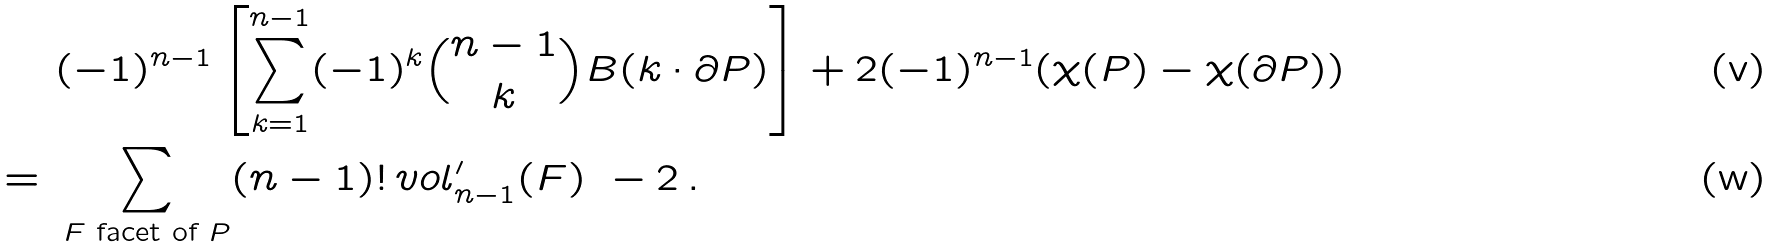<formula> <loc_0><loc_0><loc_500><loc_500>& ( - 1 ) ^ { n - 1 } \left [ \sum _ { k = 1 } ^ { n - 1 } ( - 1 ) ^ { k } \binom { n - 1 } { k } B ( k \cdot \partial P ) \right ] + 2 ( - 1 ) ^ { n - 1 } ( \chi ( P ) - \chi ( \partial P ) ) \\ = \ & \sum _ { F \text { facet of } P } ( n - 1 ) ! \, v o l _ { n - 1 } ^ { \prime } ( F ) \ - 2 \, .</formula> 